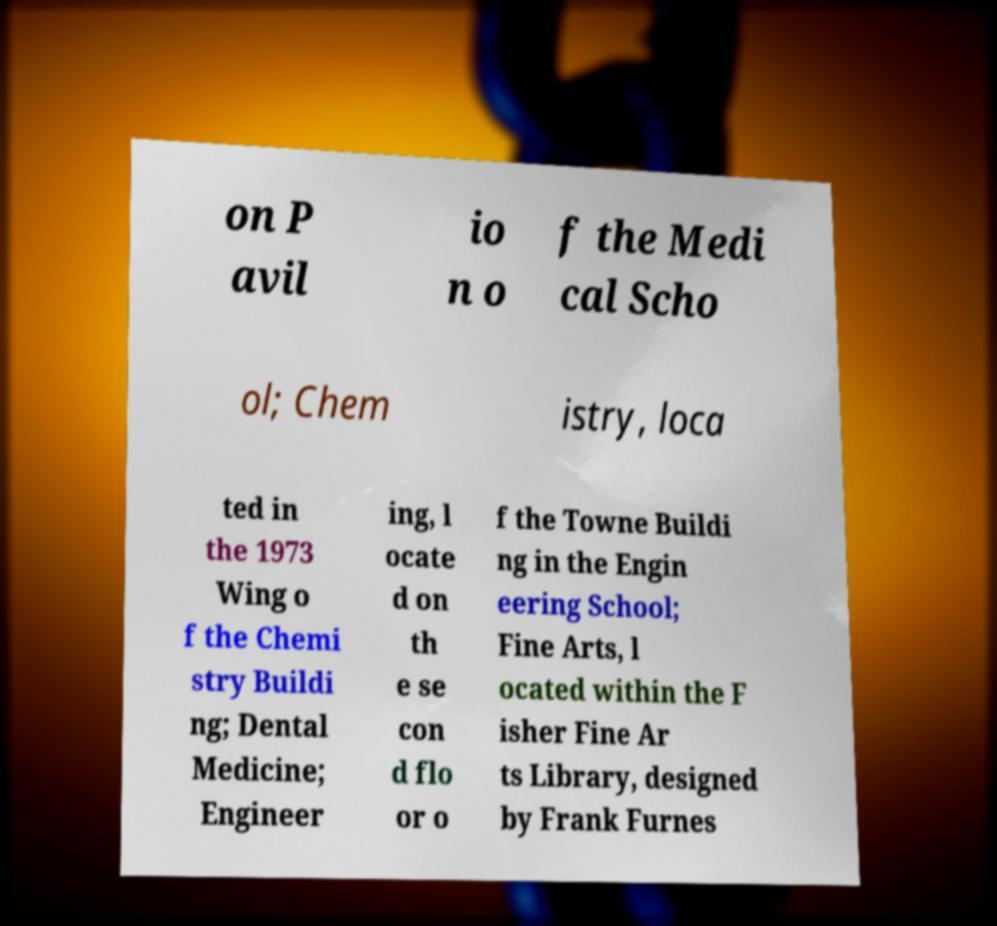For documentation purposes, I need the text within this image transcribed. Could you provide that? on P avil io n o f the Medi cal Scho ol; Chem istry, loca ted in the 1973 Wing o f the Chemi stry Buildi ng; Dental Medicine; Engineer ing, l ocate d on th e se con d flo or o f the Towne Buildi ng in the Engin eering School; Fine Arts, l ocated within the F isher Fine Ar ts Library, designed by Frank Furnes 